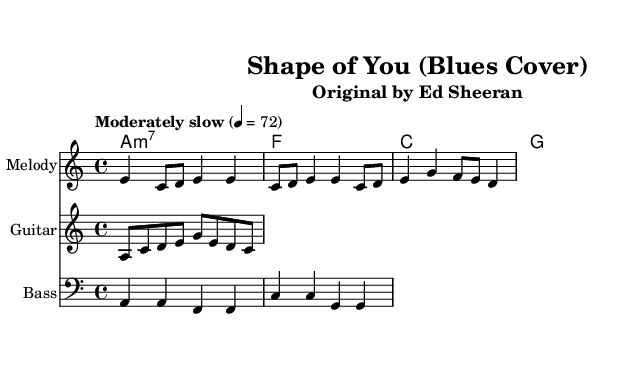What is the key signature of this music? The key signature is indicated by the 'a' in the global variable, which means it is in the key of A minor. A minor has no sharps or flats.
Answer: A minor What is the time signature of this music? The time signature is found in the global variable, which shows 4/4. This means that there are four beats per measure and the quarter note gets one beat.
Answer: 4/4 What is the tempo marking of this music? The tempo marking is found in the global variable with the words "Moderately slow" and the indication 4 = 72, meaning there are 72 beats per minute.
Answer: Moderately slow How many measures are in the melody section? By counting the number of distinct groups of notes separated by vertical lines, there are four measures in the melody section.
Answer: Four What chord follows A minor 7 in the chord progression? The chord progression is outlined in the chord mode, and after A minor 7, the next chord is F major.
Answer: F major What is the primary function of the bass line in this blues piece? The bass line typically outlines the root notes of the chords being played. In this piece, it provides a foundational rhythm and harmonic support aligning with the chords.
Answer: Harmonic support What genre is this cover showcasing? The cover is explicitly categorized as a blues rendition of a contemporary song, evidenced by its structure and style indications.
Answer: Blues 